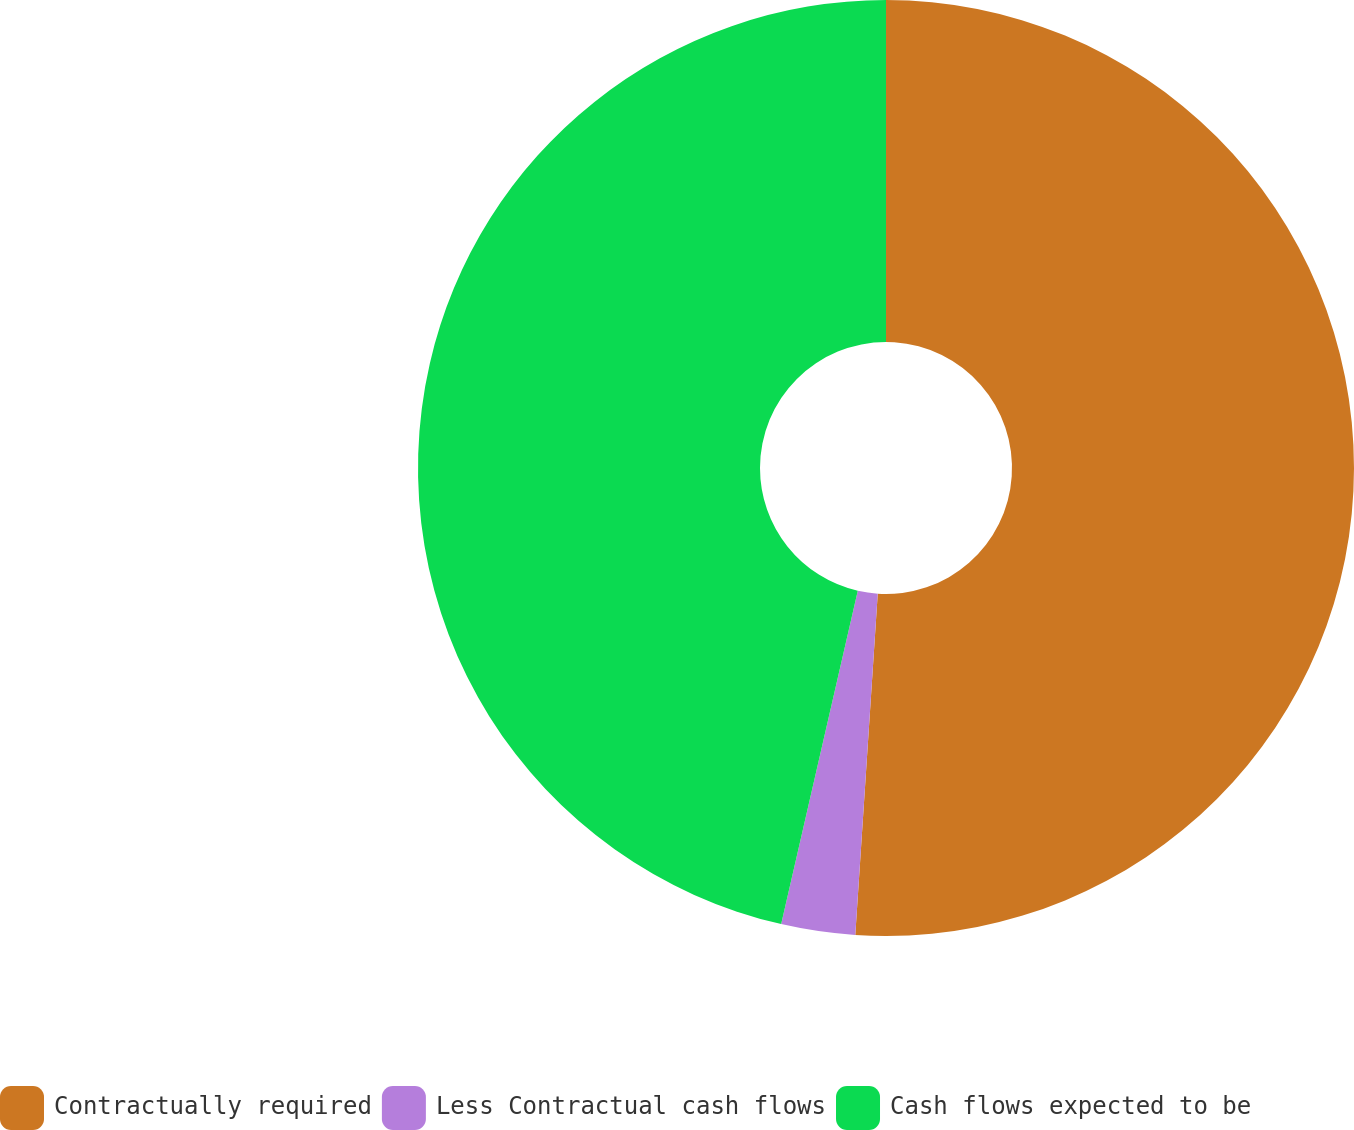Convert chart. <chart><loc_0><loc_0><loc_500><loc_500><pie_chart><fcel>Contractually required<fcel>Less Contractual cash flows<fcel>Cash flows expected to be<nl><fcel>51.04%<fcel>2.55%<fcel>46.4%<nl></chart> 